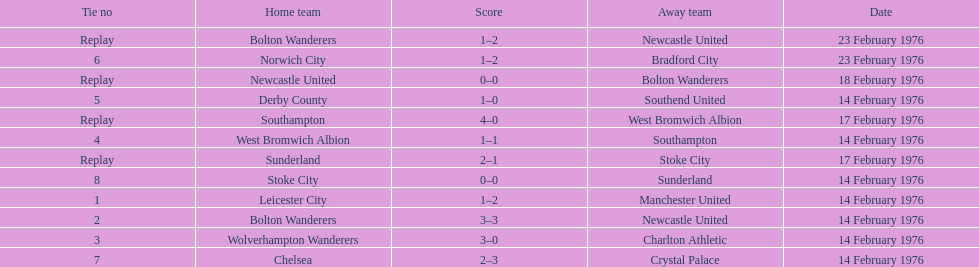Which teams played the same day as leicester city and manchester united? Bolton Wanderers, Newcastle United. 